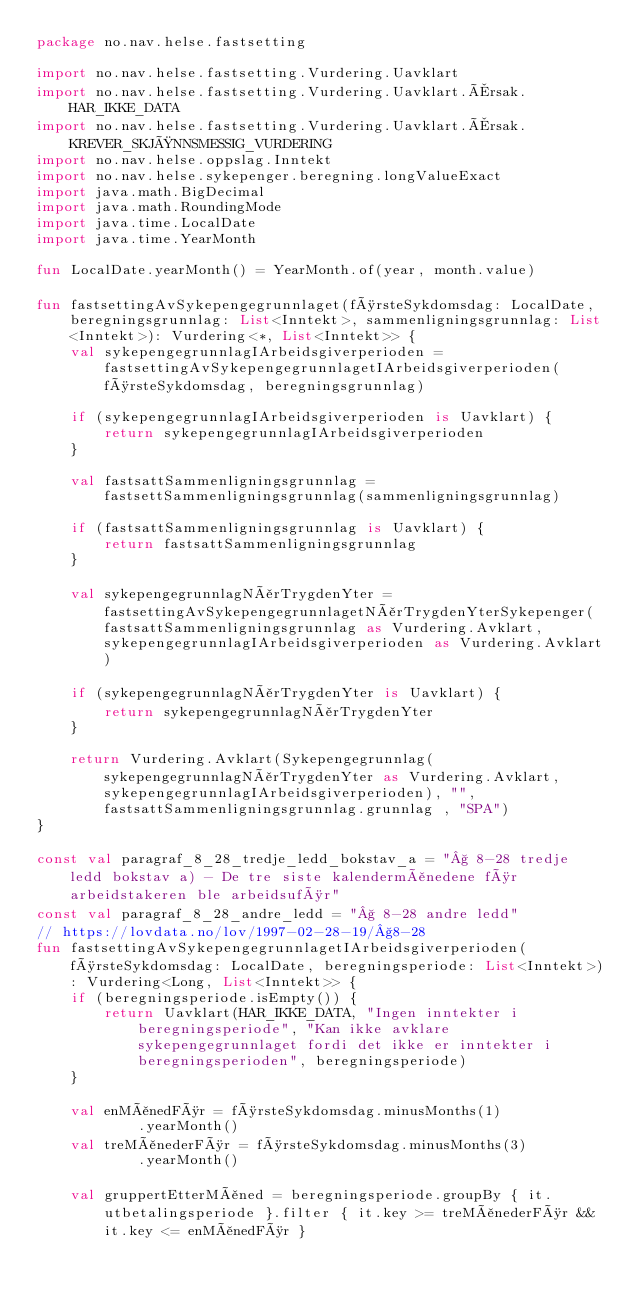<code> <loc_0><loc_0><loc_500><loc_500><_Kotlin_>package no.nav.helse.fastsetting

import no.nav.helse.fastsetting.Vurdering.Uavklart
import no.nav.helse.fastsetting.Vurdering.Uavklart.Årsak.HAR_IKKE_DATA
import no.nav.helse.fastsetting.Vurdering.Uavklart.Årsak.KREVER_SKJØNNSMESSIG_VURDERING
import no.nav.helse.oppslag.Inntekt
import no.nav.helse.sykepenger.beregning.longValueExact
import java.math.BigDecimal
import java.math.RoundingMode
import java.time.LocalDate
import java.time.YearMonth

fun LocalDate.yearMonth() = YearMonth.of(year, month.value)

fun fastsettingAvSykepengegrunnlaget(førsteSykdomsdag: LocalDate, beregningsgrunnlag: List<Inntekt>, sammenligningsgrunnlag: List<Inntekt>): Vurdering<*, List<Inntekt>> {
    val sykepengegrunnlagIArbeidsgiverperioden = fastsettingAvSykepengegrunnlagetIArbeidsgiverperioden(førsteSykdomsdag, beregningsgrunnlag)

    if (sykepengegrunnlagIArbeidsgiverperioden is Uavklart) {
        return sykepengegrunnlagIArbeidsgiverperioden
    }

    val fastsattSammenligningsgrunnlag = fastsettSammenligningsgrunnlag(sammenligningsgrunnlag)

    if (fastsattSammenligningsgrunnlag is Uavklart) {
        return fastsattSammenligningsgrunnlag
    }

    val sykepengegrunnlagNårTrygdenYter = fastsettingAvSykepengegrunnlagetNårTrygdenYterSykepenger(fastsattSammenligningsgrunnlag as Vurdering.Avklart, sykepengegrunnlagIArbeidsgiverperioden as Vurdering.Avklart)

    if (sykepengegrunnlagNårTrygdenYter is Uavklart) {
        return sykepengegrunnlagNårTrygdenYter
    }

    return Vurdering.Avklart(Sykepengegrunnlag(sykepengegrunnlagNårTrygdenYter as Vurdering.Avklart, sykepengegrunnlagIArbeidsgiverperioden), "", fastsattSammenligningsgrunnlag.grunnlag , "SPA")
}

const val paragraf_8_28_tredje_ledd_bokstav_a = "§ 8-28 tredje ledd bokstav a) - De tre siste kalendermånedene før arbeidstakeren ble arbeidsufør"
const val paragraf_8_28_andre_ledd = "§ 8-28 andre ledd"
// https://lovdata.no/lov/1997-02-28-19/§8-28
fun fastsettingAvSykepengegrunnlagetIArbeidsgiverperioden(førsteSykdomsdag: LocalDate, beregningsperiode: List<Inntekt>): Vurdering<Long, List<Inntekt>> {
    if (beregningsperiode.isEmpty()) {
        return Uavklart(HAR_IKKE_DATA, "Ingen inntekter i beregningsperiode", "Kan ikke avklare sykepengegrunnlaget fordi det ikke er inntekter i beregningsperioden", beregningsperiode)
    }

    val enMånedFør = førsteSykdomsdag.minusMonths(1)
            .yearMonth()
    val treMånederFør = førsteSykdomsdag.minusMonths(3)
            .yearMonth()

    val gruppertEtterMåned = beregningsperiode.groupBy { it.utbetalingsperiode }.filter { it.key >= treMånederFør && it.key <= enMånedFør }</code> 